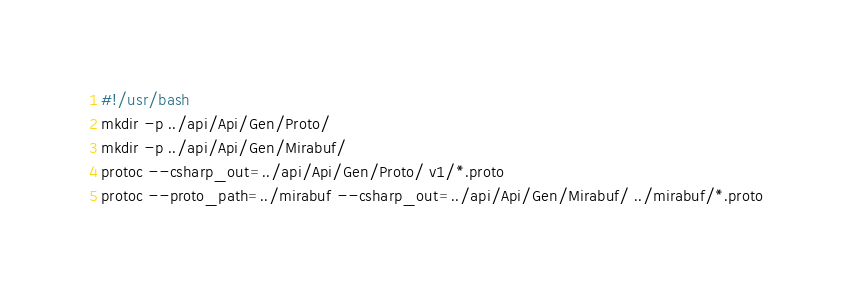Convert code to text. <code><loc_0><loc_0><loc_500><loc_500><_Bash_>#!/usr/bash
mkdir -p ../api/Api/Gen/Proto/
mkdir -p ../api/Api/Gen/Mirabuf/
protoc --csharp_out=../api/Api/Gen/Proto/ v1/*.proto
protoc --proto_path=../mirabuf --csharp_out=../api/Api/Gen/Mirabuf/ ../mirabuf/*.proto

</code> 